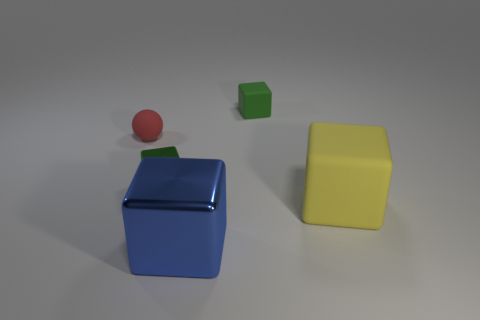Subtract all brown cylinders. How many green cubes are left? 2 Add 2 yellow matte things. How many objects exist? 7 Subtract 1 blocks. How many blocks are left? 3 Subtract all yellow blocks. How many blocks are left? 3 Subtract all small red things. Subtract all red things. How many objects are left? 3 Add 3 tiny green things. How many tiny green things are left? 5 Add 2 tiny green blocks. How many tiny green blocks exist? 4 Subtract 0 green spheres. How many objects are left? 5 Subtract all spheres. How many objects are left? 4 Subtract all brown cubes. Subtract all gray spheres. How many cubes are left? 4 